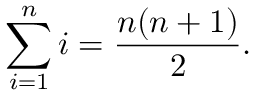<formula> <loc_0><loc_0><loc_500><loc_500>\sum _ { i = 1 } ^ { n } i = { \frac { n ( n + 1 ) } { 2 } } .</formula> 